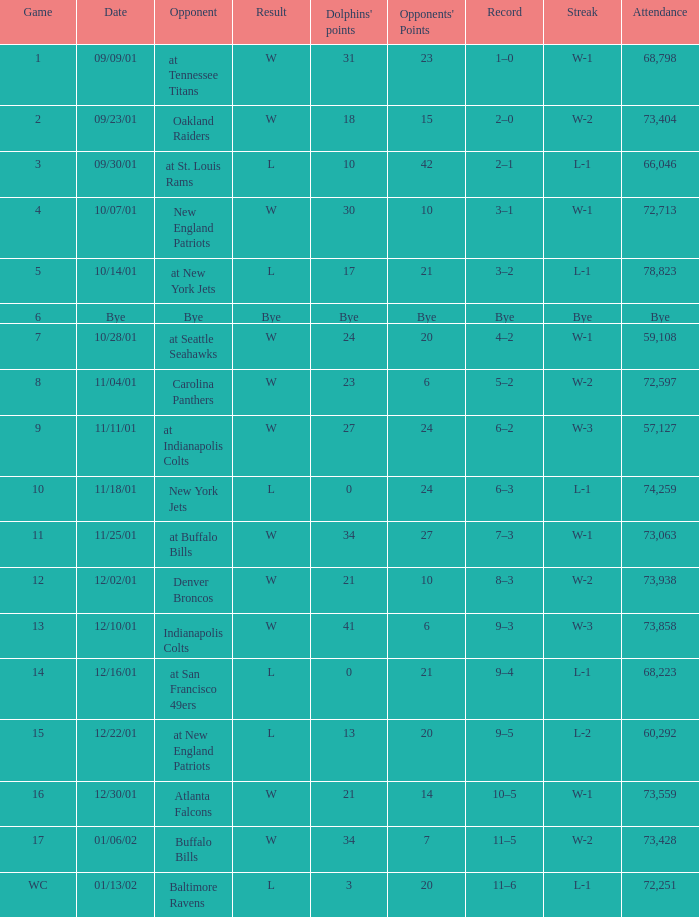What was the attendance of the Oakland Raiders game? 73404.0. 